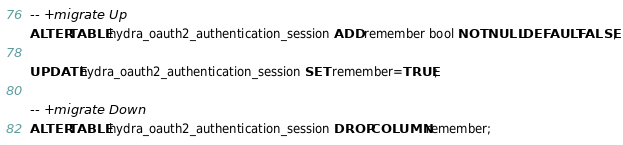Convert code to text. <code><loc_0><loc_0><loc_500><loc_500><_SQL_>-- +migrate Up
ALTER TABLE hydra_oauth2_authentication_session ADD remember bool NOT NULL DEFAULT FALSE;

UPDATE hydra_oauth2_authentication_session SET remember=TRUE;

-- +migrate Down
ALTER TABLE hydra_oauth2_authentication_session DROP COLUMN remember;
</code> 